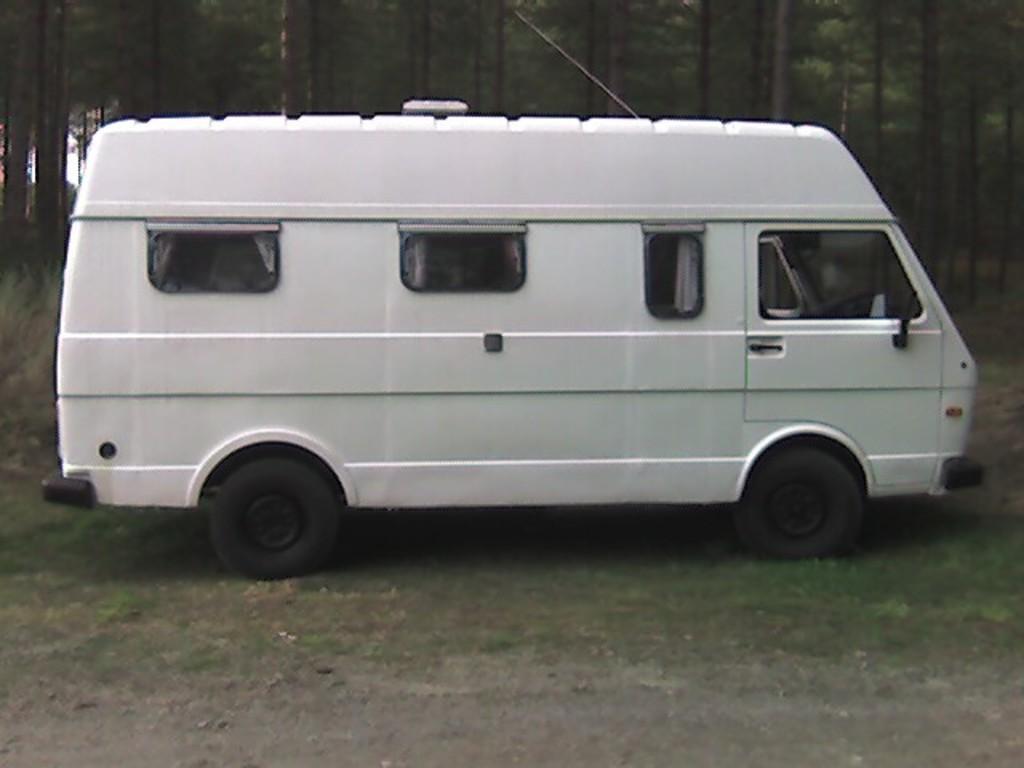How would you summarize this image in a sentence or two? In this image we can see there is a vehicle on the ground. And there is a grass. At the back there are trees. 